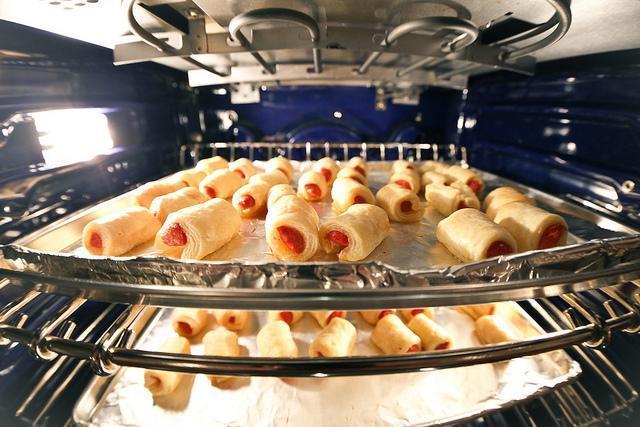How many racks are in the oven?
Give a very brief answer. 2. How many hot dogs are there?
Give a very brief answer. 7. 